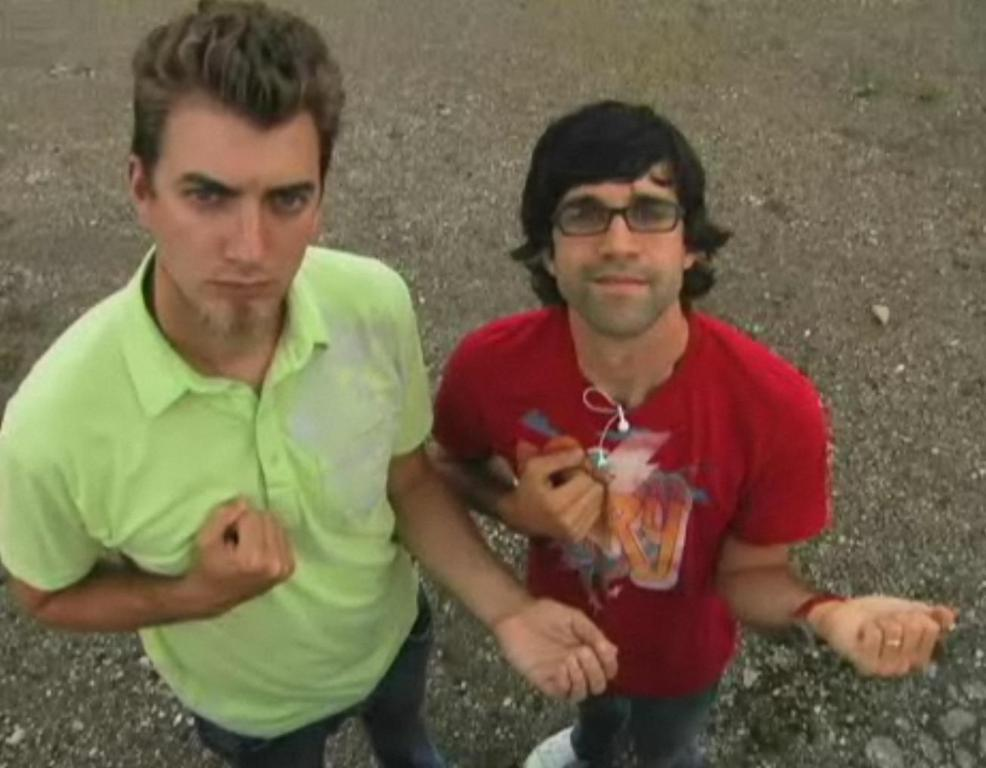How many people are in the image? There are two men in the image. What are the men doing in the image? The men are standing on the ground. What type of brain can be seen in the image? There is no brain present in the image; it features two men standing on the ground. What kind of lumber is visible in the image? There is no lumber present in the image. 